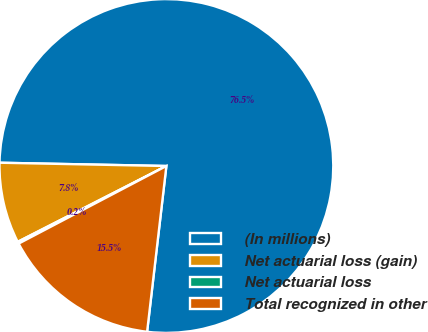<chart> <loc_0><loc_0><loc_500><loc_500><pie_chart><fcel>(In millions)<fcel>Net actuarial loss (gain)<fcel>Net actuarial loss<fcel>Total recognized in other<nl><fcel>76.53%<fcel>7.82%<fcel>0.19%<fcel>15.46%<nl></chart> 